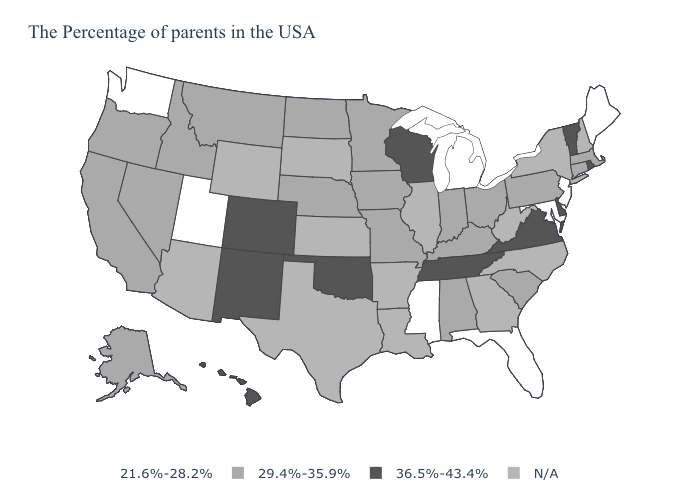Among the states that border New York , which have the lowest value?
Quick response, please. New Jersey. Does the first symbol in the legend represent the smallest category?
Concise answer only. Yes. What is the lowest value in the USA?
Be succinct. 21.6%-28.2%. What is the value of Wyoming?
Keep it brief. N/A. Among the states that border Colorado , which have the highest value?
Quick response, please. Oklahoma, New Mexico. Name the states that have a value in the range 21.6%-28.2%?
Concise answer only. Maine, New Jersey, Maryland, Florida, Michigan, Mississippi, Utah, Washington. How many symbols are there in the legend?
Short answer required. 4. What is the highest value in the South ?
Answer briefly. 36.5%-43.4%. Does the map have missing data?
Write a very short answer. Yes. What is the lowest value in the USA?
Quick response, please. 21.6%-28.2%. What is the value of Colorado?
Concise answer only. 36.5%-43.4%. How many symbols are there in the legend?
Write a very short answer. 4. Which states have the lowest value in the MidWest?
Answer briefly. Michigan. What is the value of New Jersey?
Give a very brief answer. 21.6%-28.2%. 